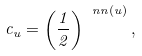<formula> <loc_0><loc_0><loc_500><loc_500>c _ { u } = \left ( \frac { 1 } { 2 } \right ) ^ { \ n n ( u ) } ,</formula> 